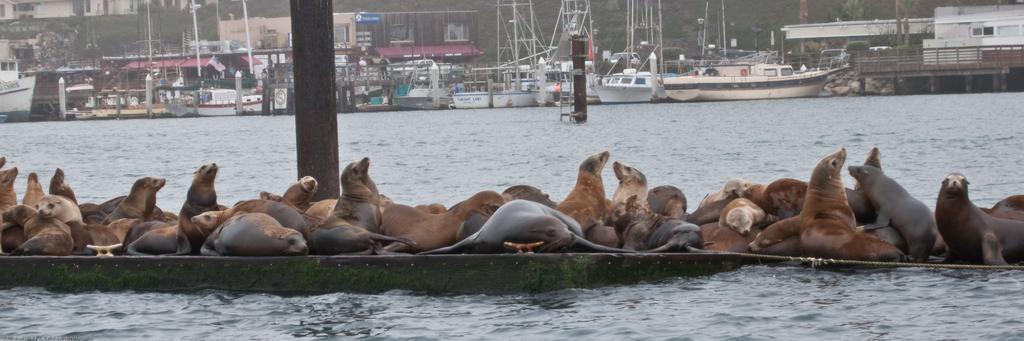Describe this image in one or two sentences. In the foreground of the image we can see group of animals on the surface, water. In the center of the image we can see some poles, staircase. In the background, we can see boats placed in water, railing, group of buildings with windows, trees and some rocks. 